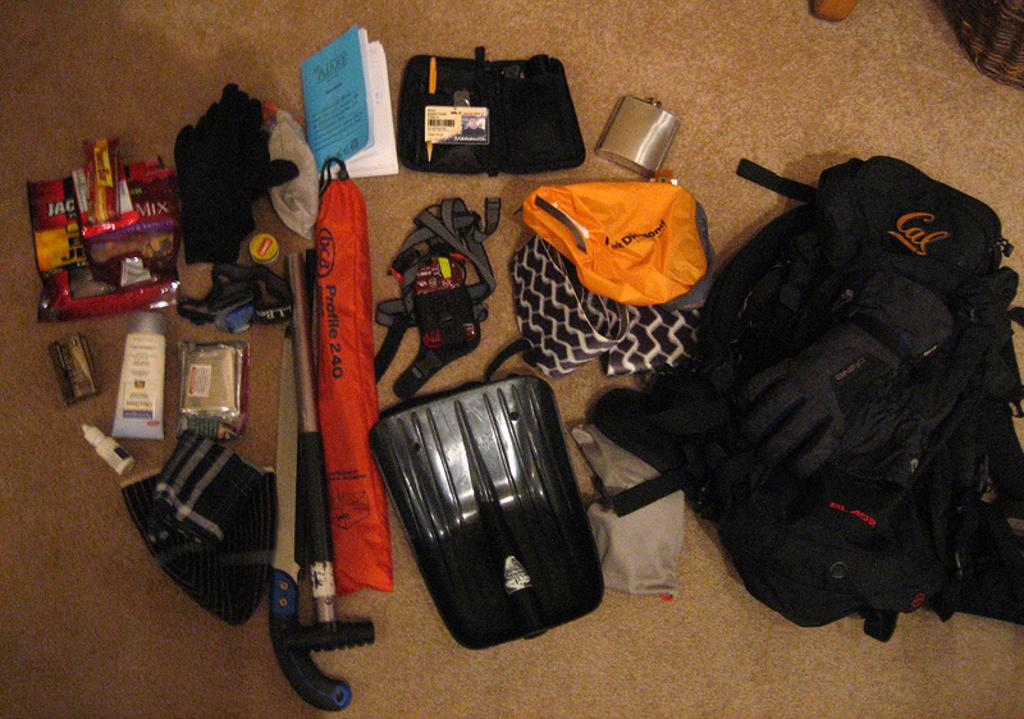What is on the floor in the image? There is a bag, gloves, a wallet, a book, cream, a wrapper, a knife, and a hammer on the floor. Can you describe the items on the floor in more detail? The bag is on the floor, as well as gloves, a wallet, a book, cream, a wrapper, a knife, and a hammer. What might be the purpose of the knife and hammer on the floor? The knife and hammer on the floor could be tools or objects that were being used or are intended for use. How many carts are visible in the image? There are no carts visible in the image. Are there any brothers in the image? There is no mention of brothers or any people in the image. 